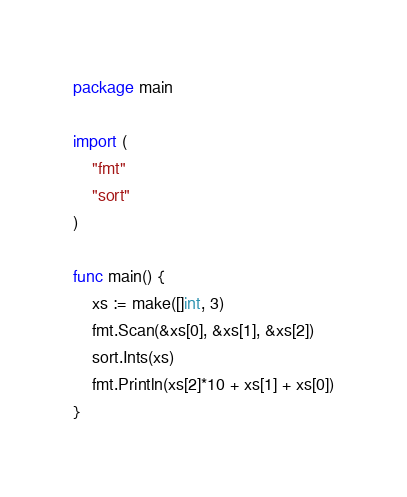Convert code to text. <code><loc_0><loc_0><loc_500><loc_500><_Go_>package main

import (
	"fmt"
	"sort"
)

func main() {
	xs := make([]int, 3)
	fmt.Scan(&xs[0], &xs[1], &xs[2])
	sort.Ints(xs)
	fmt.Println(xs[2]*10 + xs[1] + xs[0])
}
</code> 